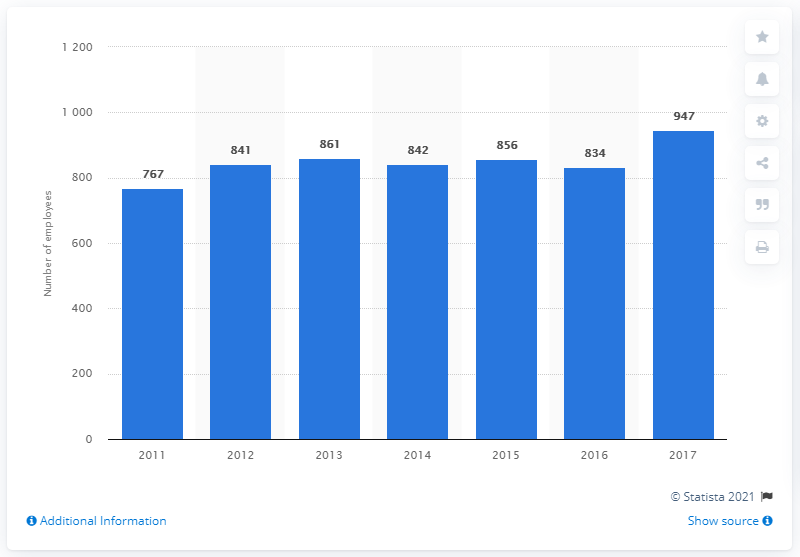Specify some key components in this picture. In 2017, Gucci had a total of 947 employees. The number of employees at the Italian luxury fashion company Guccio Gucci S.p.A. between 2014 and 2017 was 3,479. The number of employees of the Italian luxury fashion company Guccio Gucci S.p.A. in 2011 was 767. The number of employees at Gucci in the first year was 767. 